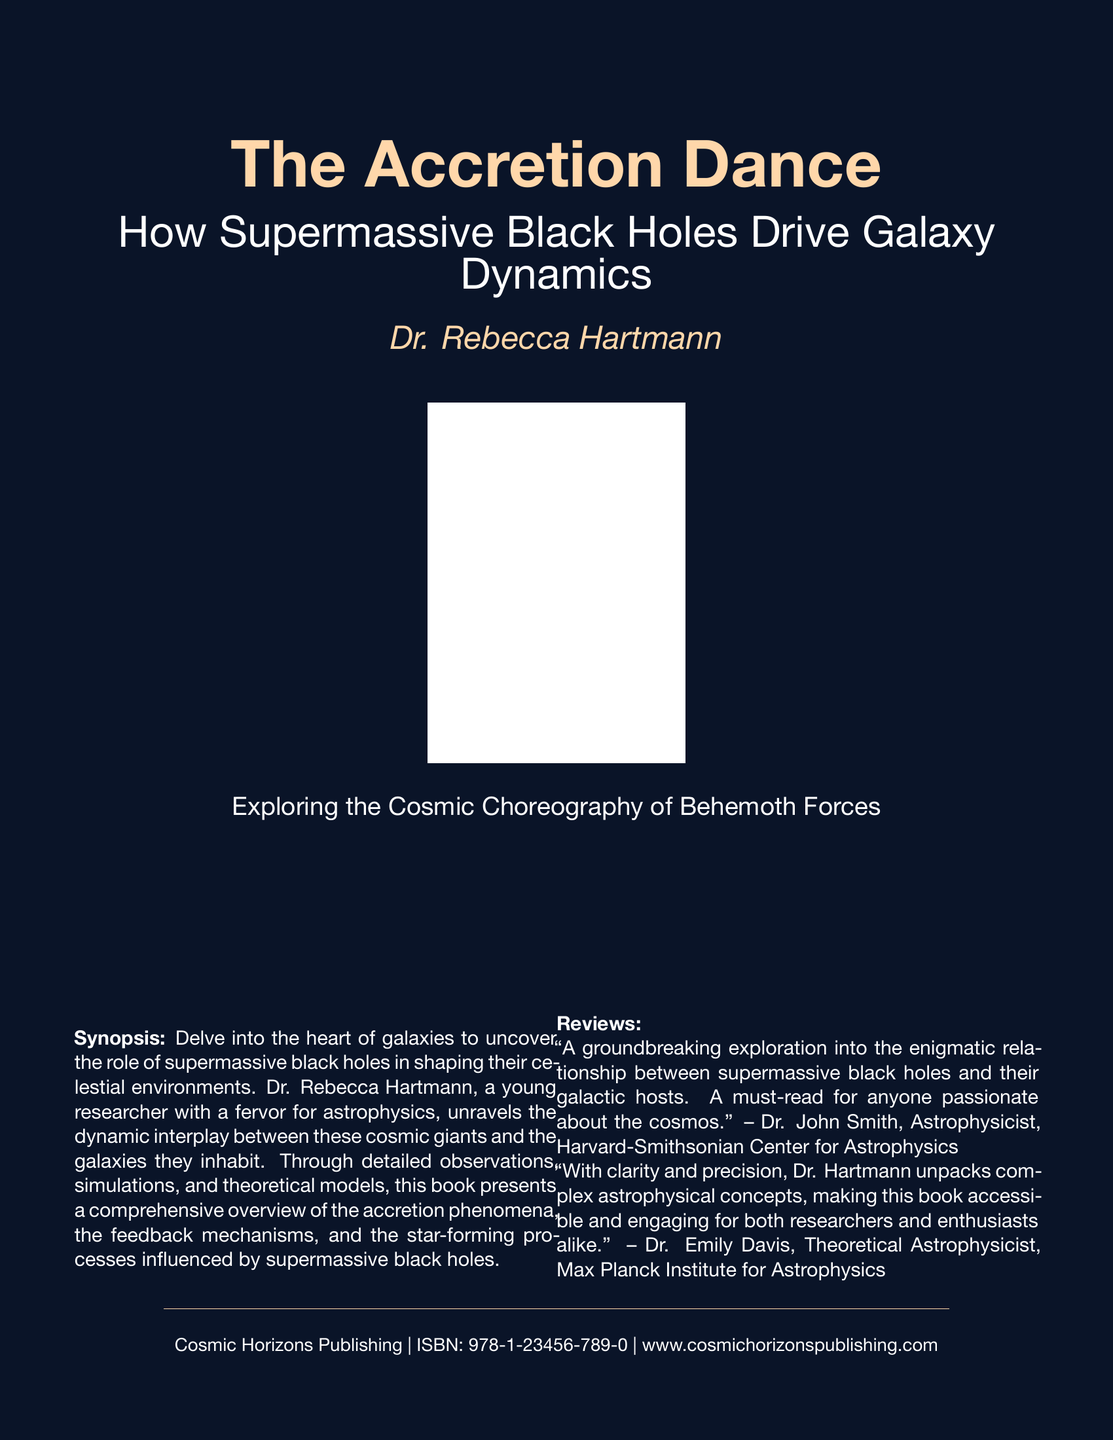What is the title of the book? The title is prominently displayed on the cover of the document, stating "The Accretion Dance".
Answer: The Accretion Dance Who is the author of the book? The author's name is listed under the title, identifying them as Dr. Rebecca Hartmann.
Answer: Dr. Rebecca Hartmann What is the main focus of the book? The book's subtitle indicates that it explores how supermassive black holes drive galaxy dynamics.
Answer: Supermassive black holes drive galaxy dynamics What is the name of the publishing company? The publishing information at the bottom of the cover indicates that it is published by Cosmic Horizons Publishing.
Answer: Cosmic Horizons Publishing What is the ISBN number of the book? The ISBN number is provided in the publication information section at the bottom of the document.
Answer: 978-1-23456-789-0 Who reviewed the book? The reviews include comments from Dr. John Smith and Dr. Emily Davis, noted astrophysicists.
Answer: Dr. John Smith, Dr. Emily Davis What aspect of astrophysics does the book delve into? The synopsis states that it uncovers the role of supermassive black holes in shaping celestial environments.
Answer: Shaping celestial environments What visual element is on the cover? The document contains a placeholder for a galaxy simulation image.
Answer: Galaxy simulation image placeholder How does Dr. Hartmann's writing style is described? Dr. Hartmann's writing is described as clear and precise, making complex concepts accessible.
Answer: Clear and precise 